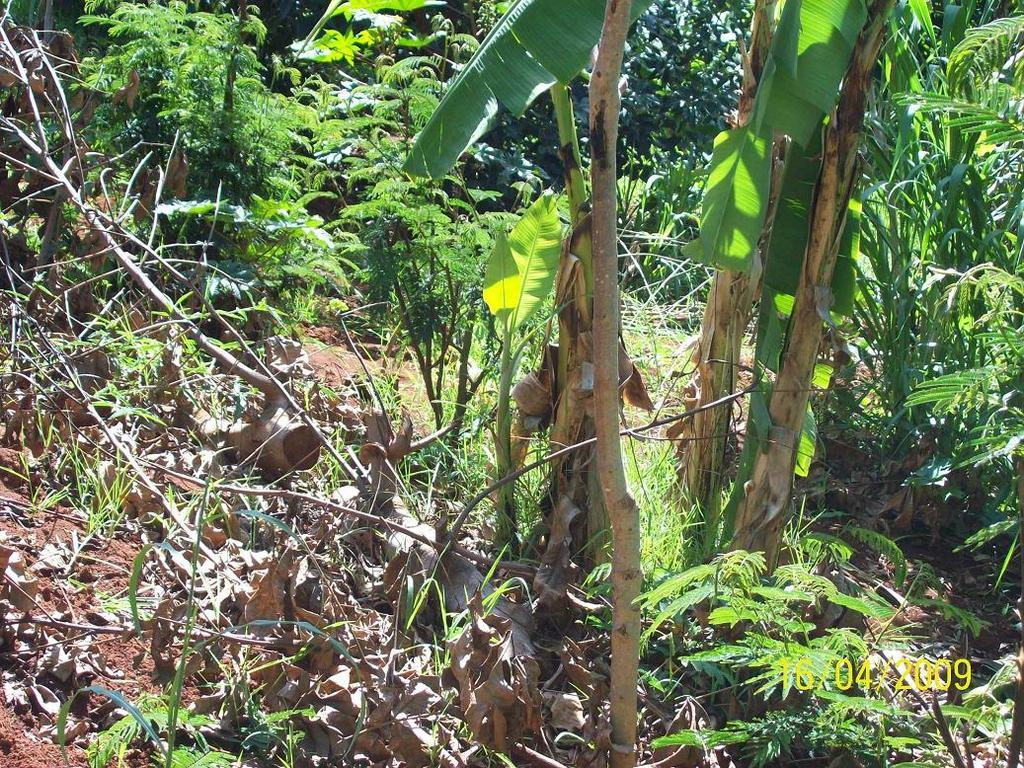What type of vegetation can be seen at the bottom of the picture? There is grass, dried leaves, and twigs visible at the bottom of the picture. What is located behind the grass, dried leaves, and twigs? There are trees behind the grass, dried leaves, and twigs. What might be the setting of the image based on the vegetation present? The image might have been taken in a garden, given the presence of grass, dried leaves, twigs, and trees. Can you tell me how many quinces are hanging from the trees in the image? There is no mention of quinces in the image; it only features grass, dried leaves, twigs, and trees. What type of wax is used to coat the dried leaves in the image? There is no wax present in the image; the dried leaves are natural and not coated with any substance. 